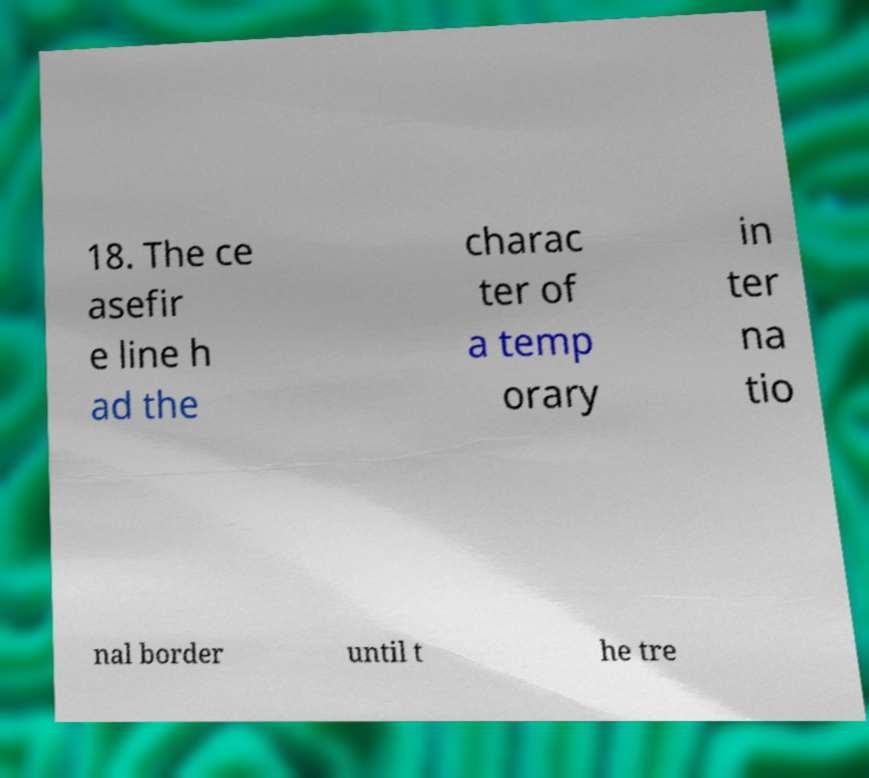There's text embedded in this image that I need extracted. Can you transcribe it verbatim? 18. The ce asefir e line h ad the charac ter of a temp orary in ter na tio nal border until t he tre 